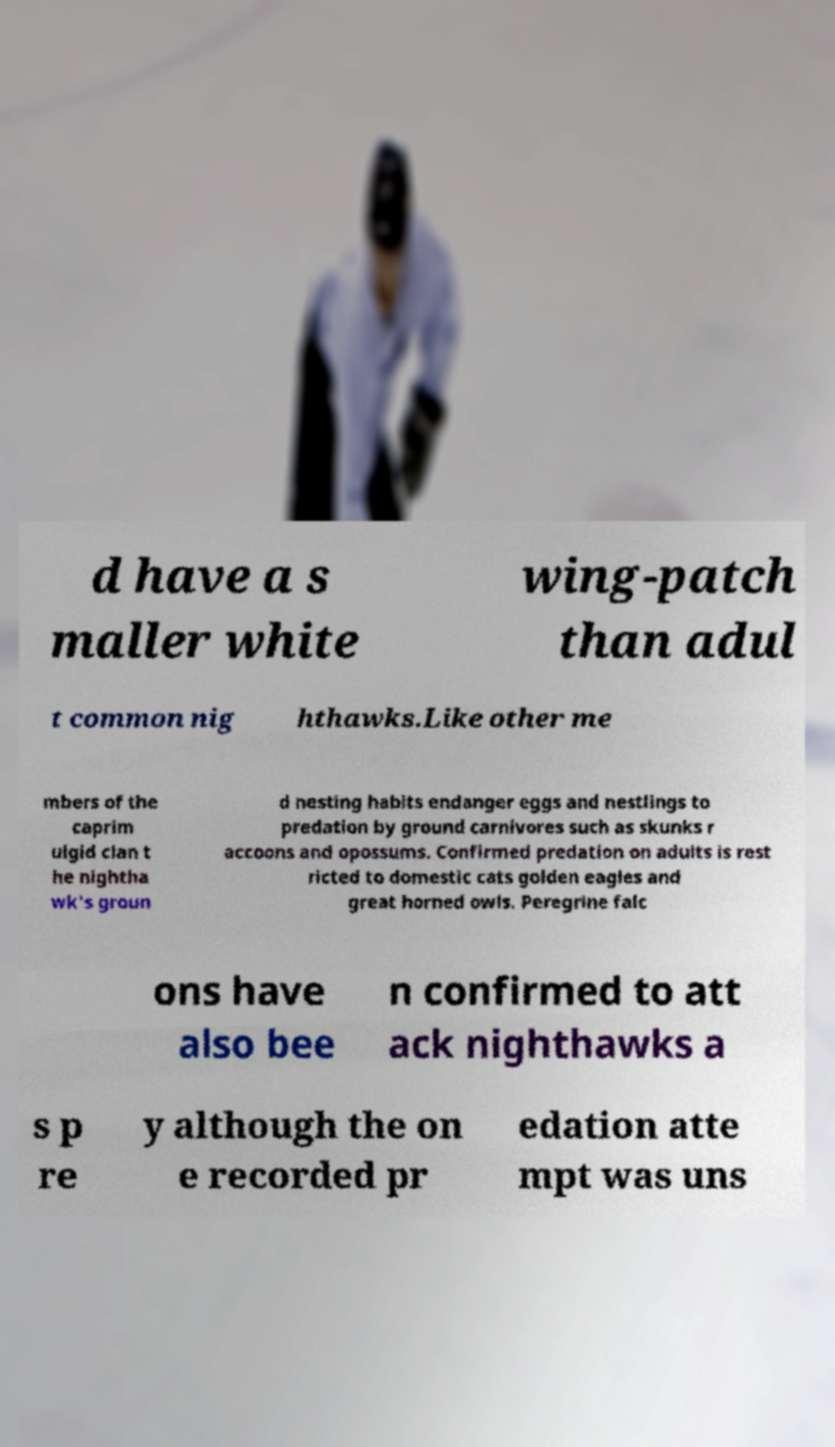What messages or text are displayed in this image? I need them in a readable, typed format. d have a s maller white wing-patch than adul t common nig hthawks.Like other me mbers of the caprim ulgid clan t he nightha wk's groun d nesting habits endanger eggs and nestlings to predation by ground carnivores such as skunks r accoons and opossums. Confirmed predation on adults is rest ricted to domestic cats golden eagles and great horned owls. Peregrine falc ons have also bee n confirmed to att ack nighthawks a s p re y although the on e recorded pr edation atte mpt was uns 